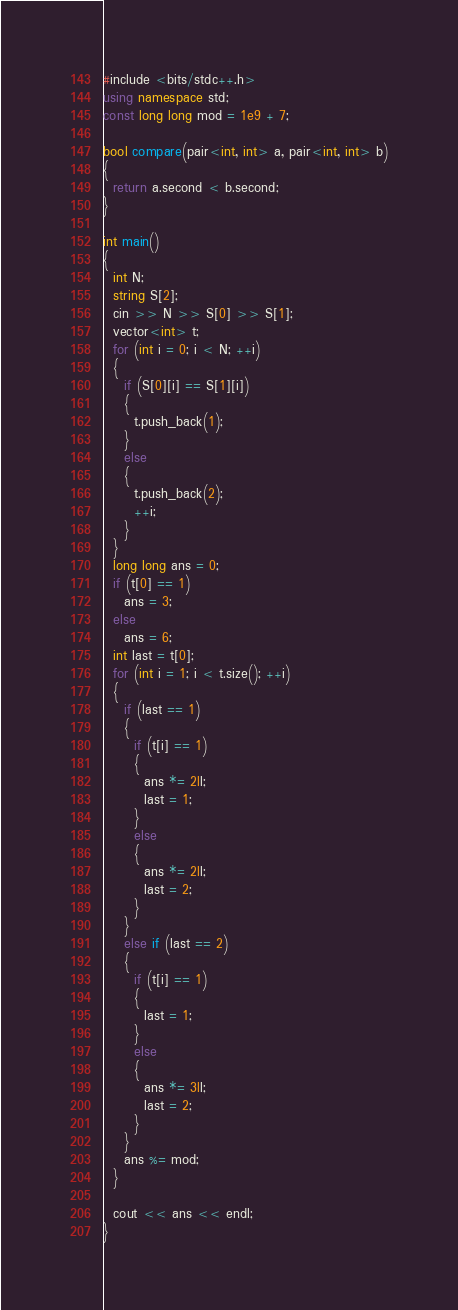Convert code to text. <code><loc_0><loc_0><loc_500><loc_500><_C#_>#include <bits/stdc++.h>
using namespace std;
const long long mod = 1e9 + 7;

bool compare(pair<int, int> a, pair<int, int> b)
{
  return a.second < b.second;
}

int main()
{
  int N;
  string S[2];
  cin >> N >> S[0] >> S[1];
  vector<int> t;
  for (int i = 0; i < N; ++i)
  {
    if (S[0][i] == S[1][i])
    {
      t.push_back(1);
    }
    else
    {
      t.push_back(2);
      ++i;
    }
  }
  long long ans = 0;
  if (t[0] == 1)
    ans = 3;
  else
    ans = 6;
  int last = t[0];
  for (int i = 1; i < t.size(); ++i)
  {
    if (last == 1)
    {
      if (t[i] == 1)
      {
        ans *= 2ll;
        last = 1;
      }
      else
      {
        ans *= 2ll;
        last = 2;
      }
    }
    else if (last == 2)
    {
      if (t[i] == 1)
      {
        last = 1;
      }
      else
      {
        ans *= 3ll;
        last = 2;
      }
    }
    ans %= mod;
  }

  cout << ans << endl;
}
</code> 